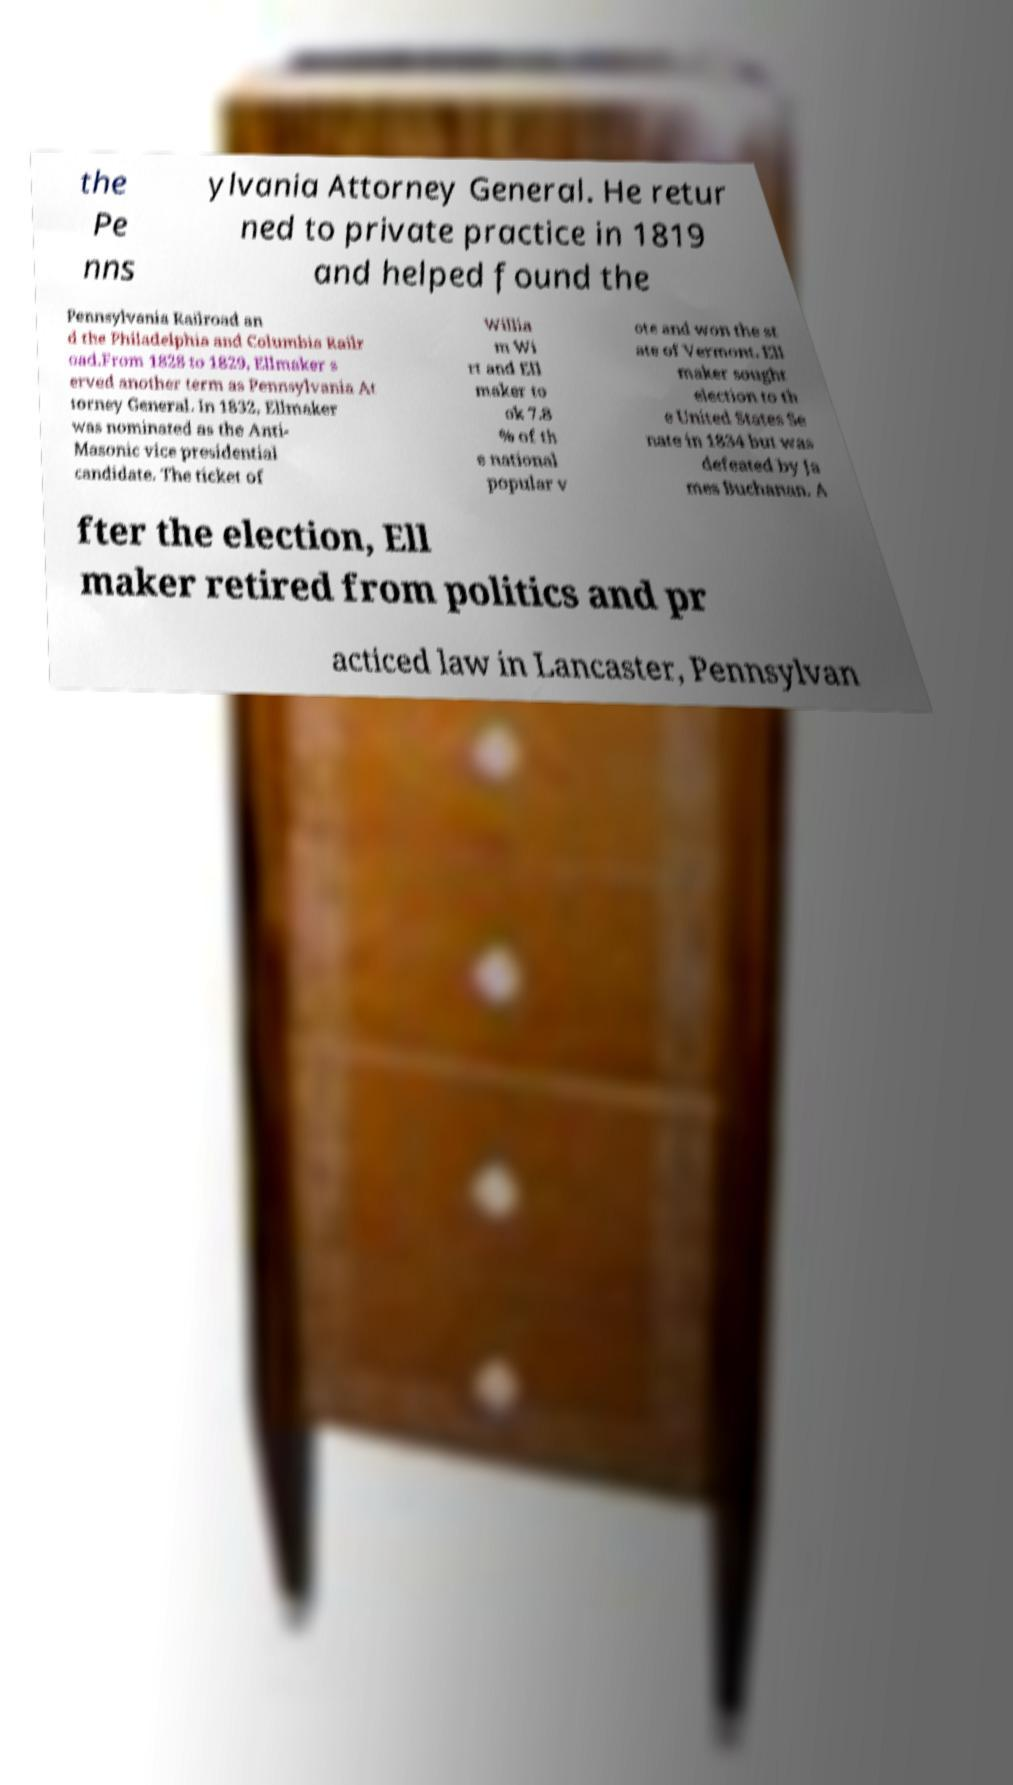Please read and relay the text visible in this image. What does it say? the Pe nns ylvania Attorney General. He retur ned to private practice in 1819 and helped found the Pennsylvania Railroad an d the Philadelphia and Columbia Railr oad.From 1828 to 1829, Ellmaker s erved another term as Pennsylvania At torney General. In 1832, Ellmaker was nominated as the Anti- Masonic vice presidential candidate. The ticket of Willia m Wi rt and Ell maker to ok 7.8 % of th e national popular v ote and won the st ate of Vermont. Ell maker sought election to th e United States Se nate in 1834 but was defeated by Ja mes Buchanan. A fter the election, Ell maker retired from politics and pr acticed law in Lancaster, Pennsylvan 